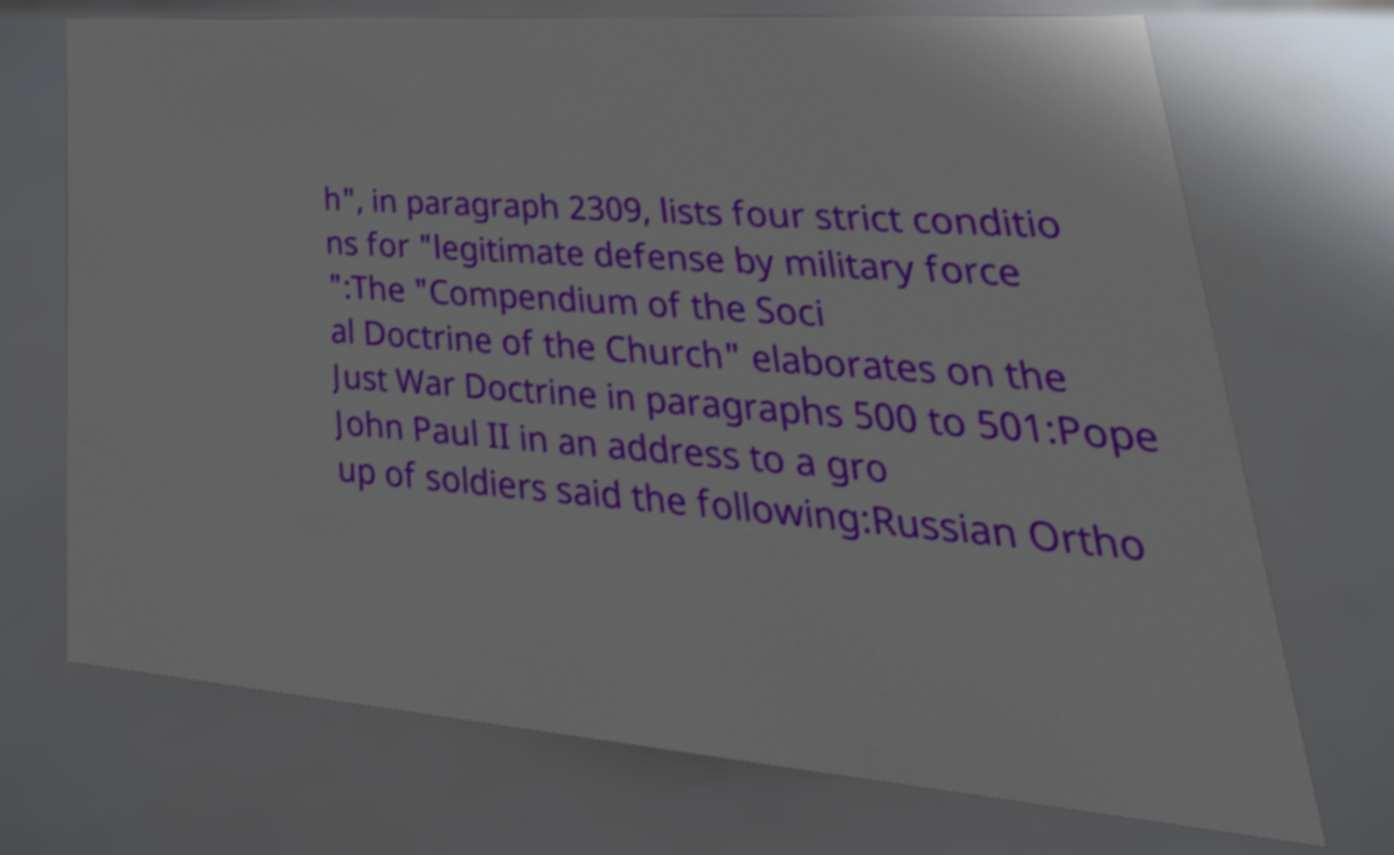What messages or text are displayed in this image? I need them in a readable, typed format. h", in paragraph 2309, lists four strict conditio ns for "legitimate defense by military force ":The "Compendium of the Soci al Doctrine of the Church" elaborates on the Just War Doctrine in paragraphs 500 to 501:Pope John Paul II in an address to a gro up of soldiers said the following:Russian Ortho 